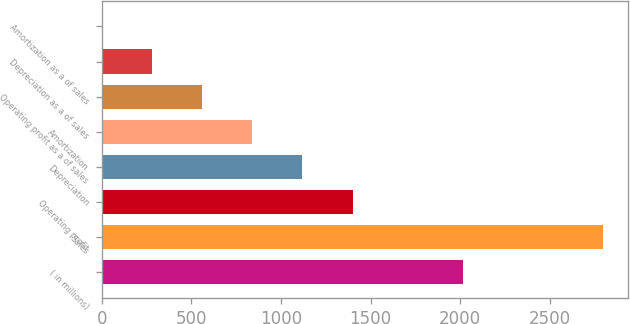<chart> <loc_0><loc_0><loc_500><loc_500><bar_chart><fcel>( in millions)<fcel>Sales<fcel>Operating profit<fcel>Depreciation<fcel>Amortization<fcel>Operating profit as a of sales<fcel>Depreciation as a of sales<fcel>Amortization as a of sales<nl><fcel>2018<fcel>2797.6<fcel>1399.35<fcel>1119.7<fcel>840.05<fcel>560.4<fcel>280.75<fcel>1.1<nl></chart> 